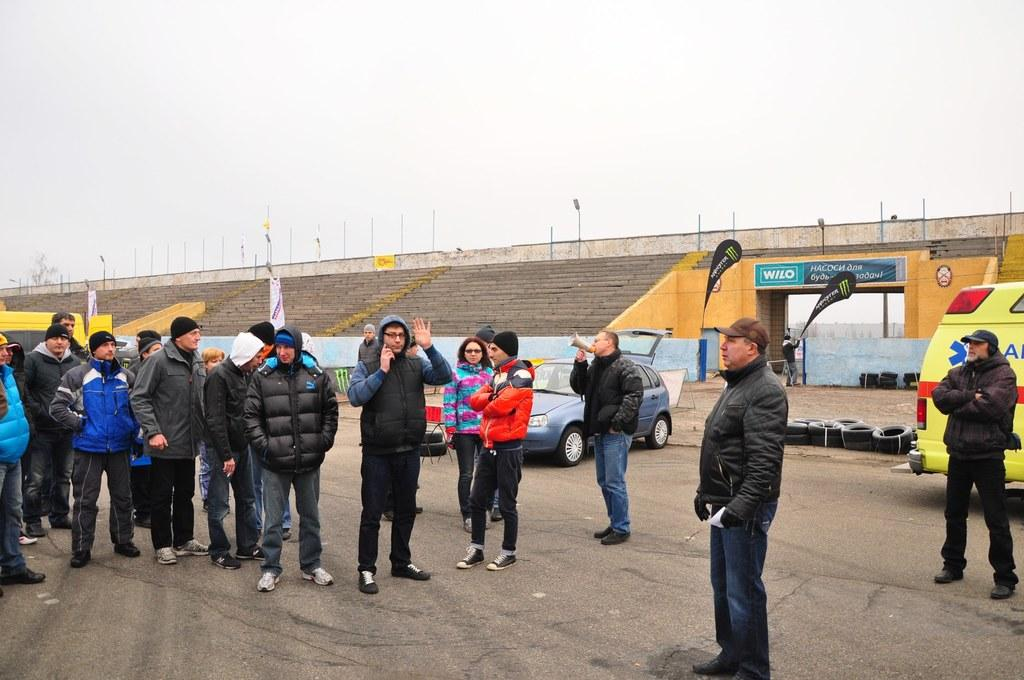What is the main subject of the image? The main subject of the image is a group of people standing. What else can be seen in the image besides the people? There are vehicles, tyres, boards, poles, lights, and stairs visible in the image. What is the condition of the sky in the background of the image? The sky is visible in the background of the image. How many sheep are present on the stage in the image? There is no stage or sheep present in the image. What is the profit margin of the company depicted in the image? There is no company or profit margin mentioned in the image. 